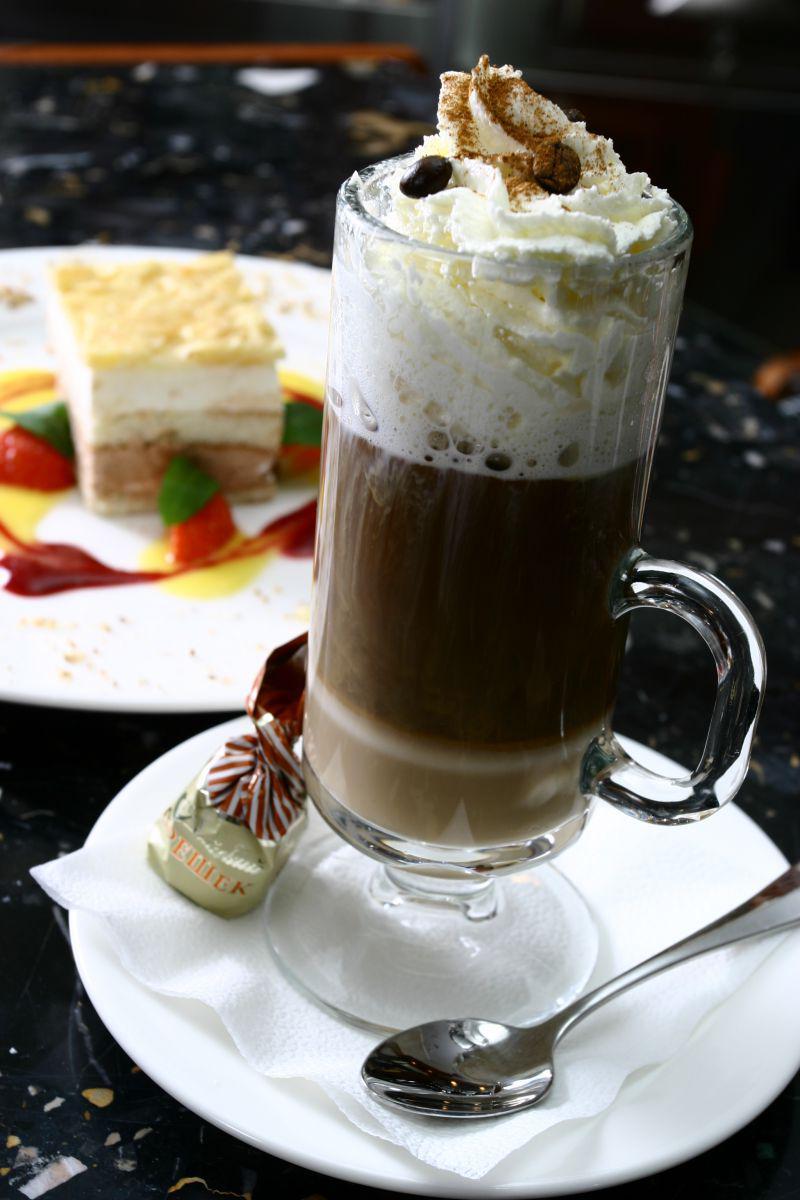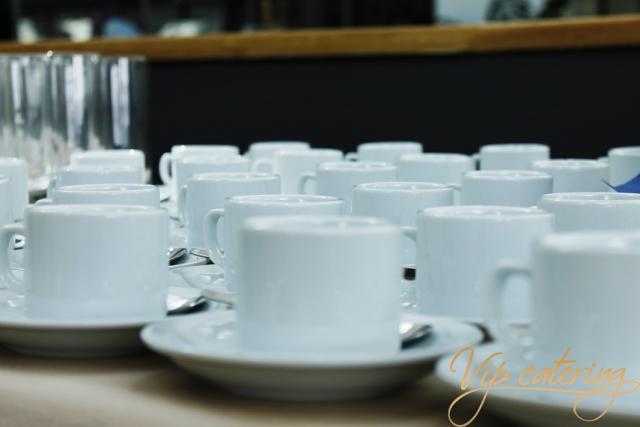The first image is the image on the left, the second image is the image on the right. Assess this claim about the two images: "The right image includes at least some rows of white coffee cups on white saucers that are not stacked on top of another white cup on a saucer.". Correct or not? Answer yes or no. Yes. The first image is the image on the left, the second image is the image on the right. Analyze the images presented: Is the assertion "At least one of the cups contains a beverage." valid? Answer yes or no. Yes. 